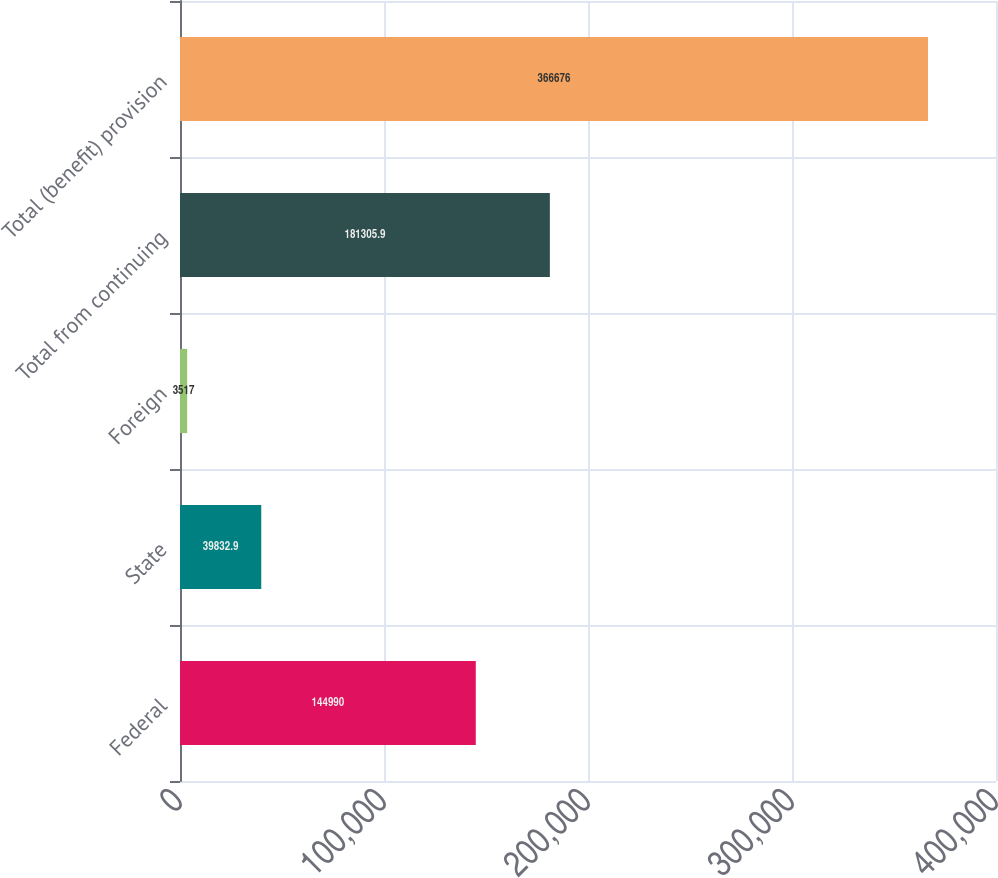Convert chart to OTSL. <chart><loc_0><loc_0><loc_500><loc_500><bar_chart><fcel>Federal<fcel>State<fcel>Foreign<fcel>Total from continuing<fcel>Total (benefit) provision<nl><fcel>144990<fcel>39832.9<fcel>3517<fcel>181306<fcel>366676<nl></chart> 